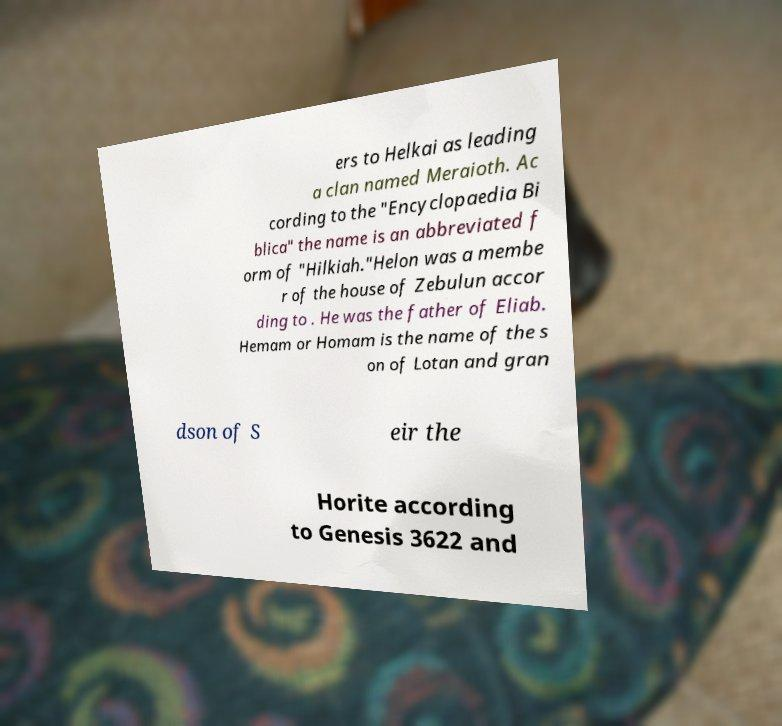What messages or text are displayed in this image? I need them in a readable, typed format. ers to Helkai as leading a clan named Meraioth. Ac cording to the "Encyclopaedia Bi blica" the name is an abbreviated f orm of "Hilkiah."Helon was a membe r of the house of Zebulun accor ding to . He was the father of Eliab. Hemam or Homam is the name of the s on of Lotan and gran dson of S eir the Horite according to Genesis 3622 and 